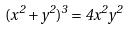<formula> <loc_0><loc_0><loc_500><loc_500>( x ^ { 2 } + y ^ { 2 } ) ^ { 3 } = 4 x ^ { 2 } y ^ { 2 }</formula> 